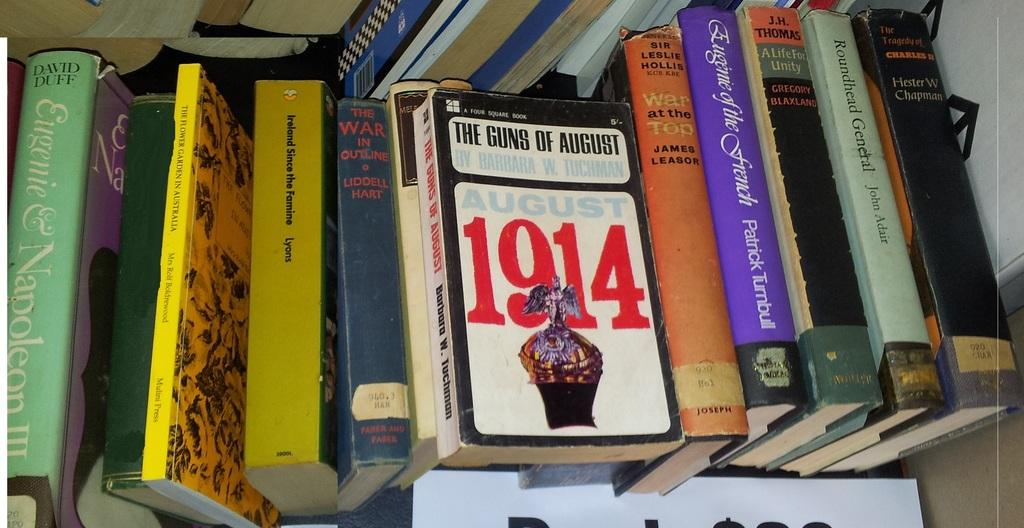<image>
Describe the image concisely. A row of books with the book 1914 on top. 